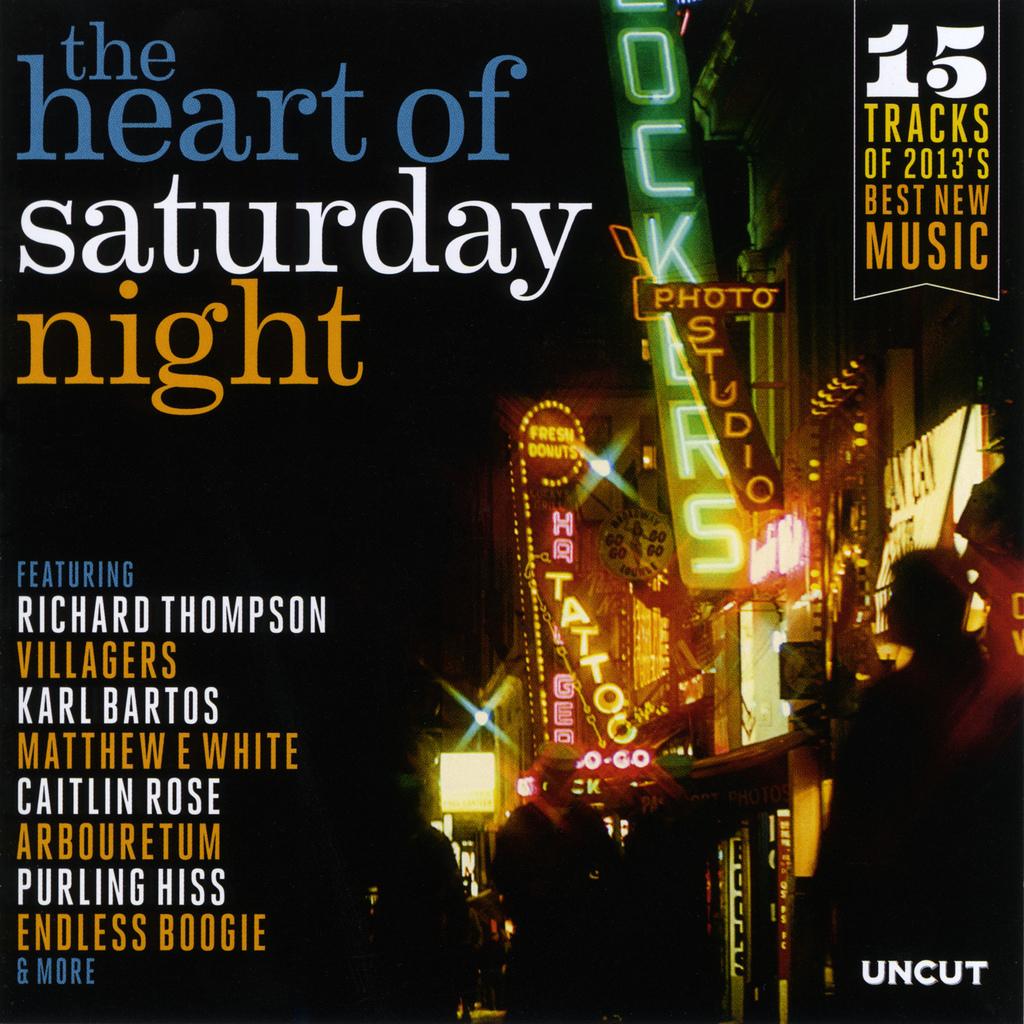Who is one of the featured people in this album?
Keep it short and to the point. Richard thompson. How many tracks are on this album?
Make the answer very short. 15. 